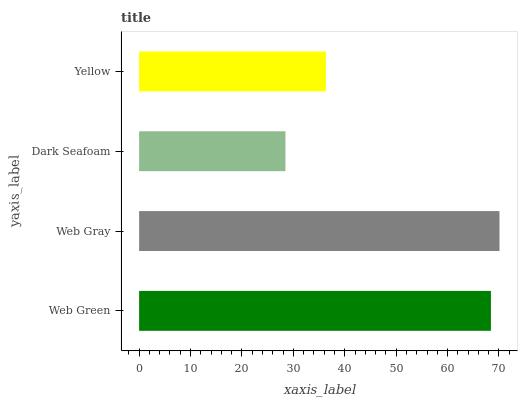Is Dark Seafoam the minimum?
Answer yes or no. Yes. Is Web Gray the maximum?
Answer yes or no. Yes. Is Web Gray the minimum?
Answer yes or no. No. Is Dark Seafoam the maximum?
Answer yes or no. No. Is Web Gray greater than Dark Seafoam?
Answer yes or no. Yes. Is Dark Seafoam less than Web Gray?
Answer yes or no. Yes. Is Dark Seafoam greater than Web Gray?
Answer yes or no. No. Is Web Gray less than Dark Seafoam?
Answer yes or no. No. Is Web Green the high median?
Answer yes or no. Yes. Is Yellow the low median?
Answer yes or no. Yes. Is Web Gray the high median?
Answer yes or no. No. Is Web Green the low median?
Answer yes or no. No. 